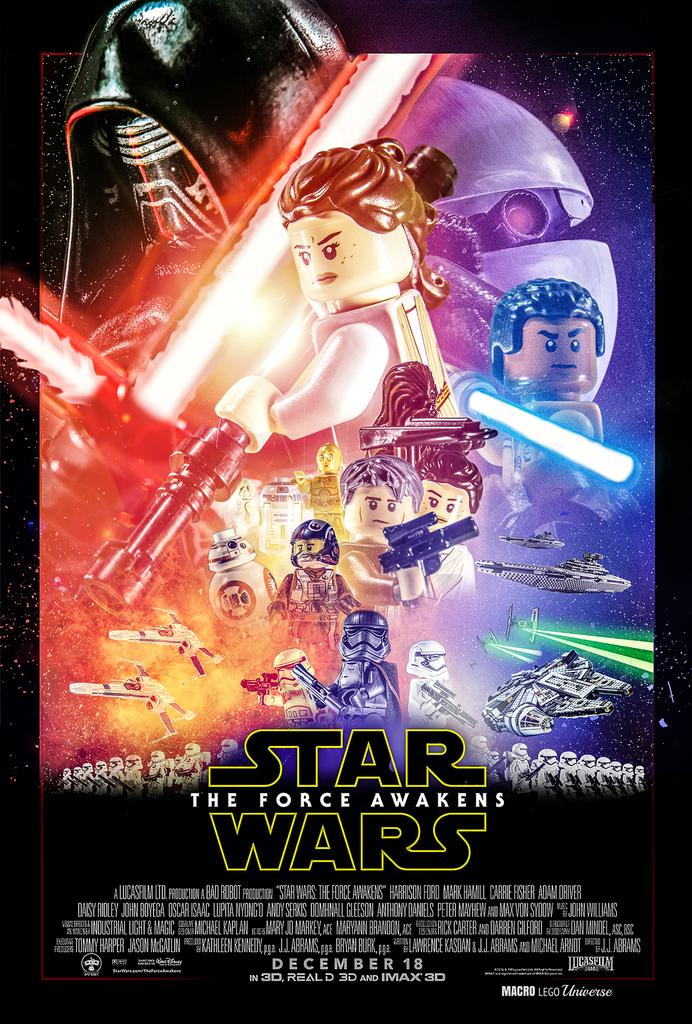<image>
Describe the image concisely. The Star Wars Force Awakens poster is recreated with LEGO figures. 